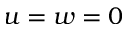Convert formula to latex. <formula><loc_0><loc_0><loc_500><loc_500>u = w = 0</formula> 